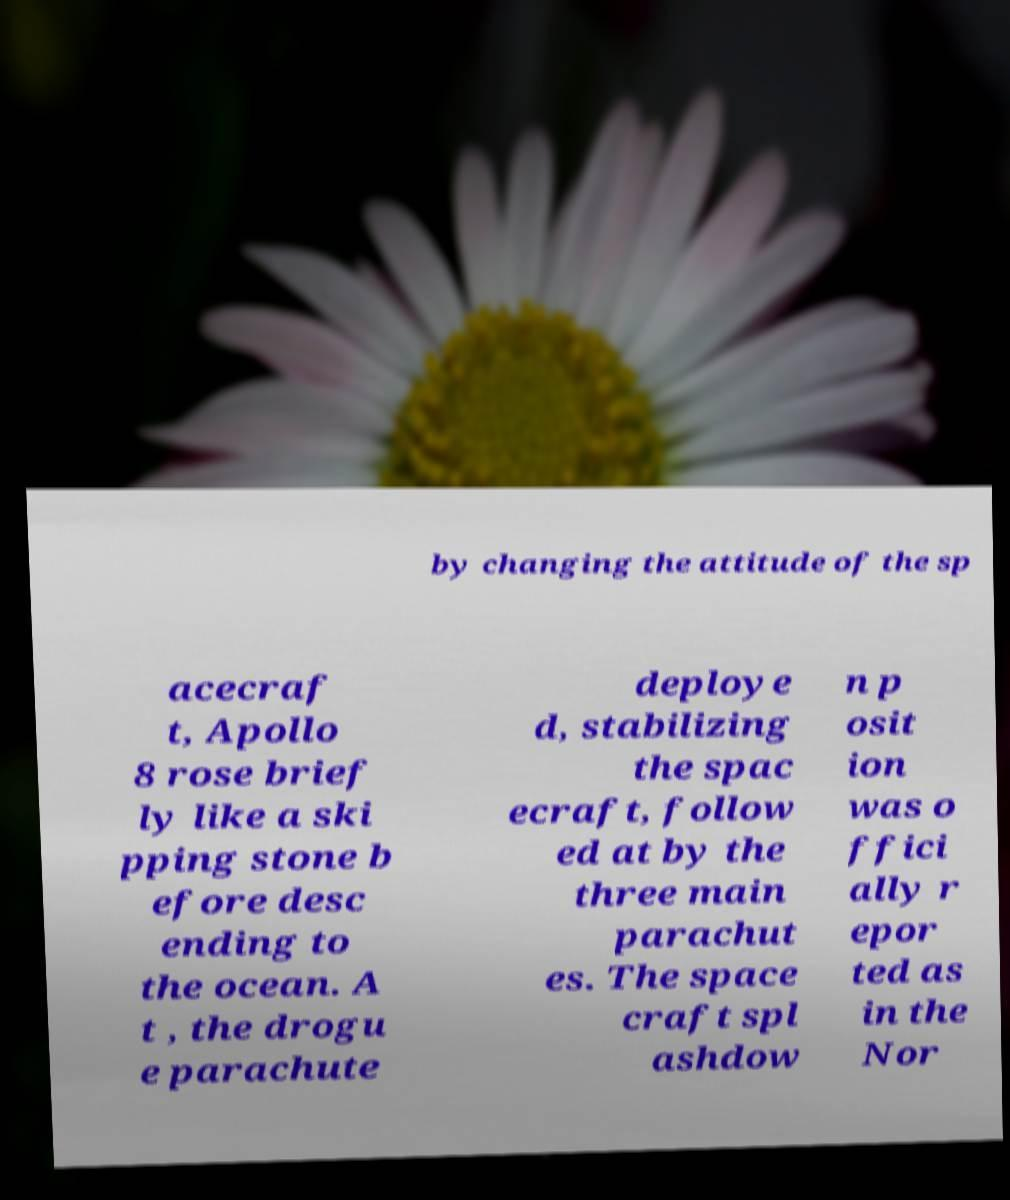I need the written content from this picture converted into text. Can you do that? by changing the attitude of the sp acecraf t, Apollo 8 rose brief ly like a ski pping stone b efore desc ending to the ocean. A t , the drogu e parachute deploye d, stabilizing the spac ecraft, follow ed at by the three main parachut es. The space craft spl ashdow n p osit ion was o ffici ally r epor ted as in the Nor 